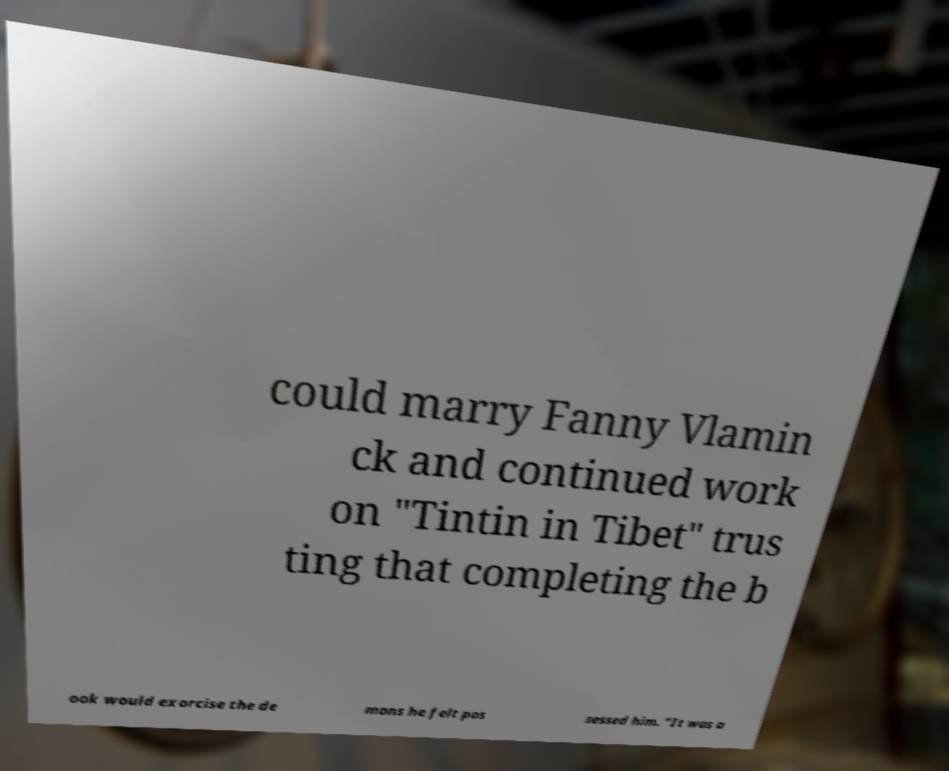There's text embedded in this image that I need extracted. Can you transcribe it verbatim? could marry Fanny Vlamin ck and continued work on "Tintin in Tibet" trus ting that completing the b ook would exorcise the de mons he felt pos sessed him. "It was a 